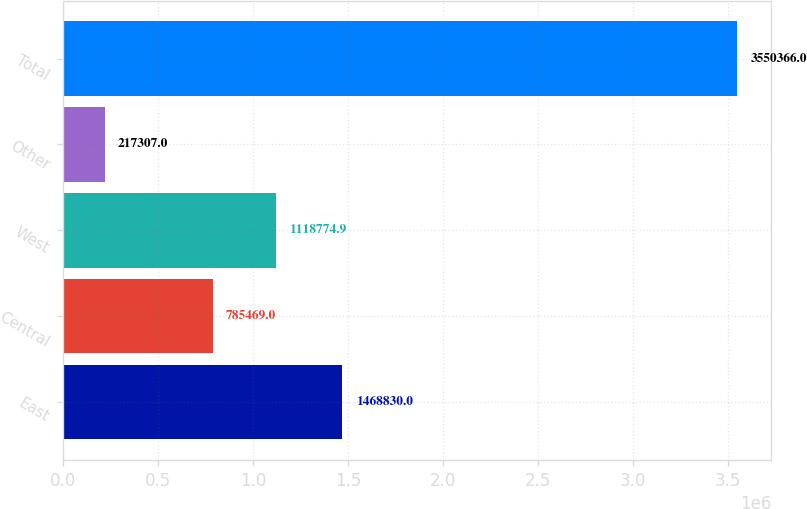Convert chart. <chart><loc_0><loc_0><loc_500><loc_500><bar_chart><fcel>East<fcel>Central<fcel>West<fcel>Other<fcel>Total<nl><fcel>1.46883e+06<fcel>785469<fcel>1.11877e+06<fcel>217307<fcel>3.55037e+06<nl></chart> 